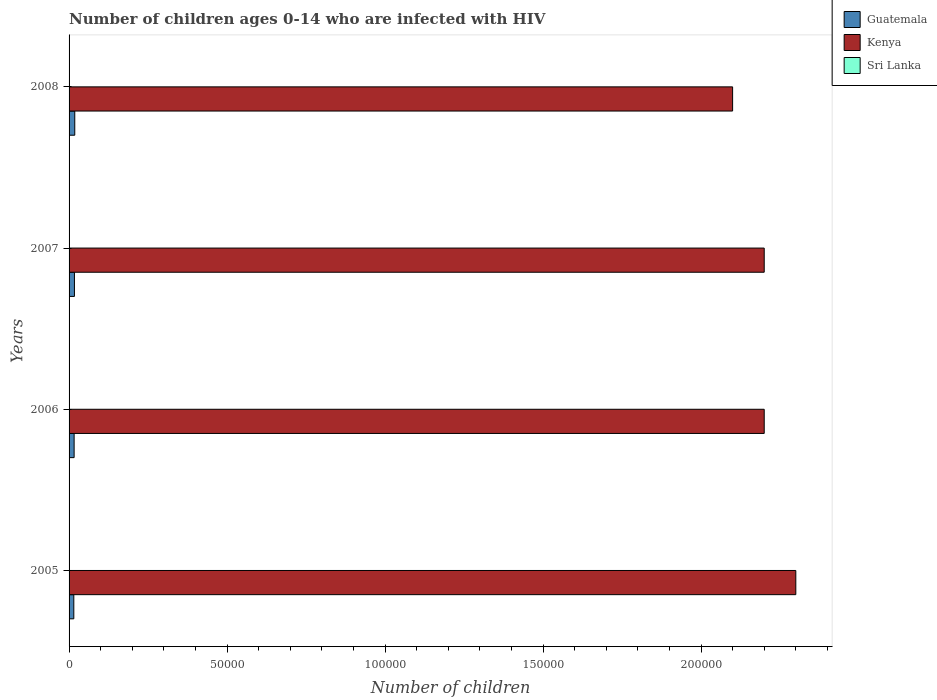How many different coloured bars are there?
Ensure brevity in your answer.  3. Are the number of bars per tick equal to the number of legend labels?
Provide a short and direct response. Yes. How many bars are there on the 2nd tick from the top?
Offer a very short reply. 3. In how many cases, is the number of bars for a given year not equal to the number of legend labels?
Offer a very short reply. 0. What is the number of HIV infected children in Guatemala in 2005?
Your answer should be compact. 1500. Across all years, what is the maximum number of HIV infected children in Guatemala?
Offer a very short reply. 1800. Across all years, what is the minimum number of HIV infected children in Kenya?
Your response must be concise. 2.10e+05. In which year was the number of HIV infected children in Kenya maximum?
Make the answer very short. 2005. What is the total number of HIV infected children in Sri Lanka in the graph?
Give a very brief answer. 400. What is the difference between the number of HIV infected children in Sri Lanka in 2005 and that in 2007?
Keep it short and to the point. 0. What is the difference between the number of HIV infected children in Kenya in 2008 and the number of HIV infected children in Sri Lanka in 2007?
Your answer should be very brief. 2.10e+05. In the year 2007, what is the difference between the number of HIV infected children in Sri Lanka and number of HIV infected children in Guatemala?
Offer a terse response. -1600. In how many years, is the number of HIV infected children in Guatemala greater than 40000 ?
Your response must be concise. 0. Is the number of HIV infected children in Guatemala in 2006 less than that in 2008?
Your answer should be very brief. Yes. Is the difference between the number of HIV infected children in Sri Lanka in 2006 and 2008 greater than the difference between the number of HIV infected children in Guatemala in 2006 and 2008?
Offer a terse response. Yes. What is the difference between the highest and the lowest number of HIV infected children in Sri Lanka?
Provide a succinct answer. 0. In how many years, is the number of HIV infected children in Sri Lanka greater than the average number of HIV infected children in Sri Lanka taken over all years?
Offer a terse response. 0. What does the 2nd bar from the top in 2005 represents?
Give a very brief answer. Kenya. What does the 2nd bar from the bottom in 2005 represents?
Provide a succinct answer. Kenya. Is it the case that in every year, the sum of the number of HIV infected children in Sri Lanka and number of HIV infected children in Guatemala is greater than the number of HIV infected children in Kenya?
Your answer should be very brief. No. How many bars are there?
Offer a terse response. 12. What is the difference between two consecutive major ticks on the X-axis?
Provide a short and direct response. 5.00e+04. Are the values on the major ticks of X-axis written in scientific E-notation?
Keep it short and to the point. No. Does the graph contain any zero values?
Give a very brief answer. No. What is the title of the graph?
Keep it short and to the point. Number of children ages 0-14 who are infected with HIV. What is the label or title of the X-axis?
Your answer should be very brief. Number of children. What is the label or title of the Y-axis?
Provide a short and direct response. Years. What is the Number of children of Guatemala in 2005?
Your response must be concise. 1500. What is the Number of children in Kenya in 2005?
Your response must be concise. 2.30e+05. What is the Number of children of Guatemala in 2006?
Ensure brevity in your answer.  1600. What is the Number of children of Kenya in 2006?
Your response must be concise. 2.20e+05. What is the Number of children in Guatemala in 2007?
Keep it short and to the point. 1700. What is the Number of children in Sri Lanka in 2007?
Offer a terse response. 100. What is the Number of children in Guatemala in 2008?
Keep it short and to the point. 1800. What is the Number of children of Sri Lanka in 2008?
Offer a terse response. 100. Across all years, what is the maximum Number of children in Guatemala?
Offer a very short reply. 1800. Across all years, what is the maximum Number of children in Sri Lanka?
Give a very brief answer. 100. Across all years, what is the minimum Number of children of Guatemala?
Provide a succinct answer. 1500. What is the total Number of children of Guatemala in the graph?
Provide a succinct answer. 6600. What is the total Number of children of Kenya in the graph?
Your answer should be compact. 8.80e+05. What is the difference between the Number of children of Guatemala in 2005 and that in 2006?
Keep it short and to the point. -100. What is the difference between the Number of children in Kenya in 2005 and that in 2006?
Offer a terse response. 10000. What is the difference between the Number of children in Guatemala in 2005 and that in 2007?
Keep it short and to the point. -200. What is the difference between the Number of children in Kenya in 2005 and that in 2007?
Your answer should be compact. 10000. What is the difference between the Number of children of Sri Lanka in 2005 and that in 2007?
Your answer should be very brief. 0. What is the difference between the Number of children of Guatemala in 2005 and that in 2008?
Your answer should be very brief. -300. What is the difference between the Number of children of Sri Lanka in 2005 and that in 2008?
Give a very brief answer. 0. What is the difference between the Number of children in Guatemala in 2006 and that in 2007?
Keep it short and to the point. -100. What is the difference between the Number of children in Kenya in 2006 and that in 2007?
Make the answer very short. 0. What is the difference between the Number of children of Guatemala in 2006 and that in 2008?
Make the answer very short. -200. What is the difference between the Number of children of Sri Lanka in 2006 and that in 2008?
Your answer should be compact. 0. What is the difference between the Number of children of Guatemala in 2007 and that in 2008?
Your response must be concise. -100. What is the difference between the Number of children of Kenya in 2007 and that in 2008?
Keep it short and to the point. 10000. What is the difference between the Number of children of Guatemala in 2005 and the Number of children of Kenya in 2006?
Provide a succinct answer. -2.18e+05. What is the difference between the Number of children in Guatemala in 2005 and the Number of children in Sri Lanka in 2006?
Provide a succinct answer. 1400. What is the difference between the Number of children of Kenya in 2005 and the Number of children of Sri Lanka in 2006?
Give a very brief answer. 2.30e+05. What is the difference between the Number of children of Guatemala in 2005 and the Number of children of Kenya in 2007?
Your answer should be compact. -2.18e+05. What is the difference between the Number of children in Guatemala in 2005 and the Number of children in Sri Lanka in 2007?
Offer a terse response. 1400. What is the difference between the Number of children in Kenya in 2005 and the Number of children in Sri Lanka in 2007?
Give a very brief answer. 2.30e+05. What is the difference between the Number of children in Guatemala in 2005 and the Number of children in Kenya in 2008?
Your answer should be very brief. -2.08e+05. What is the difference between the Number of children in Guatemala in 2005 and the Number of children in Sri Lanka in 2008?
Your answer should be compact. 1400. What is the difference between the Number of children of Kenya in 2005 and the Number of children of Sri Lanka in 2008?
Provide a succinct answer. 2.30e+05. What is the difference between the Number of children of Guatemala in 2006 and the Number of children of Kenya in 2007?
Offer a very short reply. -2.18e+05. What is the difference between the Number of children of Guatemala in 2006 and the Number of children of Sri Lanka in 2007?
Offer a terse response. 1500. What is the difference between the Number of children in Kenya in 2006 and the Number of children in Sri Lanka in 2007?
Your answer should be very brief. 2.20e+05. What is the difference between the Number of children of Guatemala in 2006 and the Number of children of Kenya in 2008?
Give a very brief answer. -2.08e+05. What is the difference between the Number of children in Guatemala in 2006 and the Number of children in Sri Lanka in 2008?
Make the answer very short. 1500. What is the difference between the Number of children of Kenya in 2006 and the Number of children of Sri Lanka in 2008?
Provide a short and direct response. 2.20e+05. What is the difference between the Number of children in Guatemala in 2007 and the Number of children in Kenya in 2008?
Your answer should be very brief. -2.08e+05. What is the difference between the Number of children in Guatemala in 2007 and the Number of children in Sri Lanka in 2008?
Give a very brief answer. 1600. What is the difference between the Number of children of Kenya in 2007 and the Number of children of Sri Lanka in 2008?
Your answer should be very brief. 2.20e+05. What is the average Number of children in Guatemala per year?
Offer a very short reply. 1650. What is the average Number of children of Kenya per year?
Offer a terse response. 2.20e+05. What is the average Number of children of Sri Lanka per year?
Keep it short and to the point. 100. In the year 2005, what is the difference between the Number of children in Guatemala and Number of children in Kenya?
Give a very brief answer. -2.28e+05. In the year 2005, what is the difference between the Number of children in Guatemala and Number of children in Sri Lanka?
Give a very brief answer. 1400. In the year 2005, what is the difference between the Number of children in Kenya and Number of children in Sri Lanka?
Your answer should be very brief. 2.30e+05. In the year 2006, what is the difference between the Number of children of Guatemala and Number of children of Kenya?
Offer a very short reply. -2.18e+05. In the year 2006, what is the difference between the Number of children of Guatemala and Number of children of Sri Lanka?
Provide a succinct answer. 1500. In the year 2006, what is the difference between the Number of children of Kenya and Number of children of Sri Lanka?
Offer a terse response. 2.20e+05. In the year 2007, what is the difference between the Number of children of Guatemala and Number of children of Kenya?
Ensure brevity in your answer.  -2.18e+05. In the year 2007, what is the difference between the Number of children of Guatemala and Number of children of Sri Lanka?
Offer a very short reply. 1600. In the year 2007, what is the difference between the Number of children in Kenya and Number of children in Sri Lanka?
Provide a short and direct response. 2.20e+05. In the year 2008, what is the difference between the Number of children in Guatemala and Number of children in Kenya?
Your answer should be compact. -2.08e+05. In the year 2008, what is the difference between the Number of children of Guatemala and Number of children of Sri Lanka?
Offer a terse response. 1700. In the year 2008, what is the difference between the Number of children of Kenya and Number of children of Sri Lanka?
Make the answer very short. 2.10e+05. What is the ratio of the Number of children in Guatemala in 2005 to that in 2006?
Your answer should be compact. 0.94. What is the ratio of the Number of children of Kenya in 2005 to that in 2006?
Ensure brevity in your answer.  1.05. What is the ratio of the Number of children of Sri Lanka in 2005 to that in 2006?
Your answer should be compact. 1. What is the ratio of the Number of children in Guatemala in 2005 to that in 2007?
Offer a terse response. 0.88. What is the ratio of the Number of children of Kenya in 2005 to that in 2007?
Give a very brief answer. 1.05. What is the ratio of the Number of children of Sri Lanka in 2005 to that in 2007?
Your answer should be compact. 1. What is the ratio of the Number of children in Guatemala in 2005 to that in 2008?
Offer a very short reply. 0.83. What is the ratio of the Number of children of Kenya in 2005 to that in 2008?
Give a very brief answer. 1.1. What is the ratio of the Number of children in Sri Lanka in 2005 to that in 2008?
Your answer should be compact. 1. What is the ratio of the Number of children of Guatemala in 2006 to that in 2007?
Offer a terse response. 0.94. What is the ratio of the Number of children of Kenya in 2006 to that in 2008?
Your answer should be compact. 1.05. What is the ratio of the Number of children of Sri Lanka in 2006 to that in 2008?
Make the answer very short. 1. What is the ratio of the Number of children in Kenya in 2007 to that in 2008?
Offer a terse response. 1.05. What is the ratio of the Number of children in Sri Lanka in 2007 to that in 2008?
Give a very brief answer. 1. What is the difference between the highest and the second highest Number of children in Kenya?
Make the answer very short. 10000. What is the difference between the highest and the second highest Number of children of Sri Lanka?
Ensure brevity in your answer.  0. What is the difference between the highest and the lowest Number of children of Guatemala?
Make the answer very short. 300. 